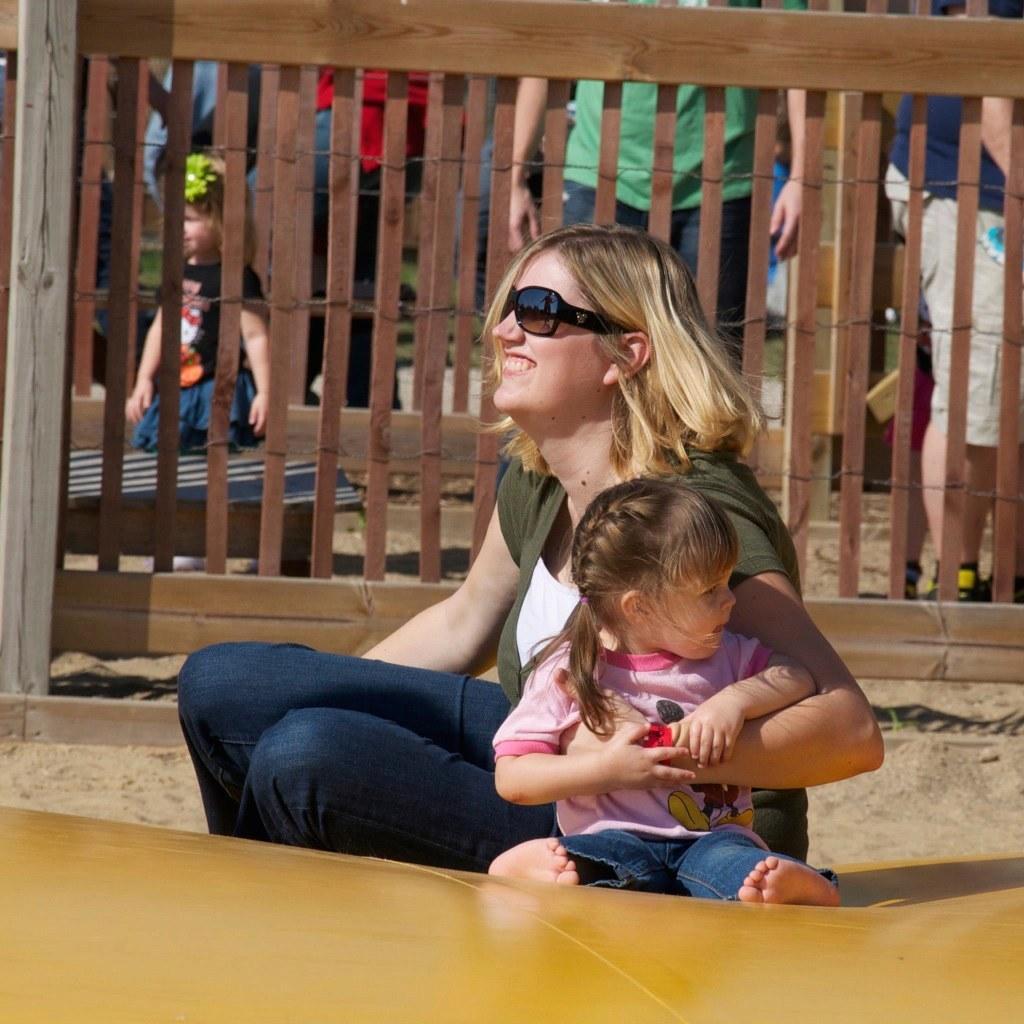In one or two sentences, can you explain what this image depicts? This is a picture of a woman wearing sunglasses is sitting on a yellow colored surface and holding a baby. In the background, we can see a few people are standing and there is a wooden fence. 